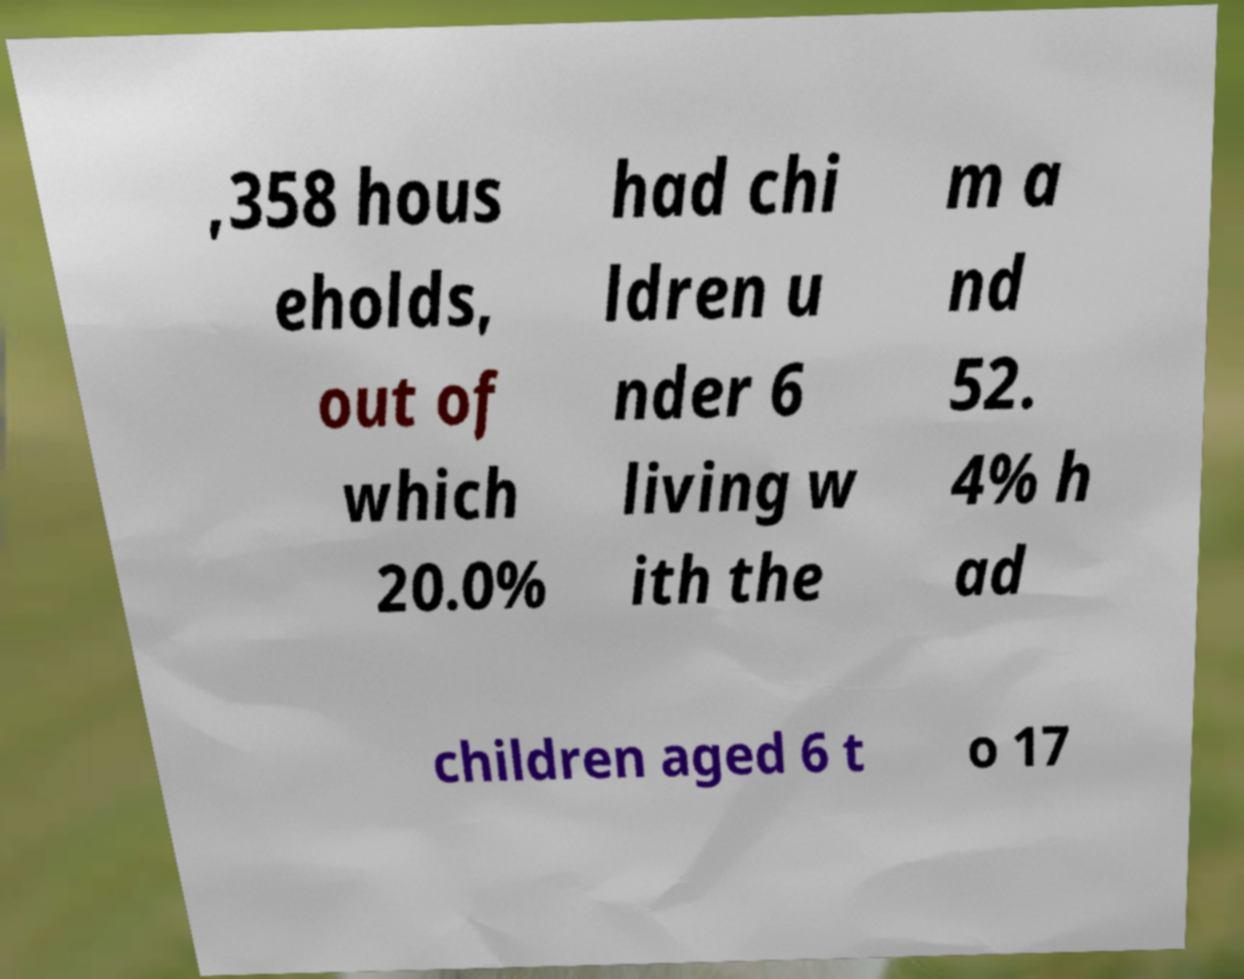Could you extract and type out the text from this image? ,358 hous eholds, out of which 20.0% had chi ldren u nder 6 living w ith the m a nd 52. 4% h ad children aged 6 t o 17 